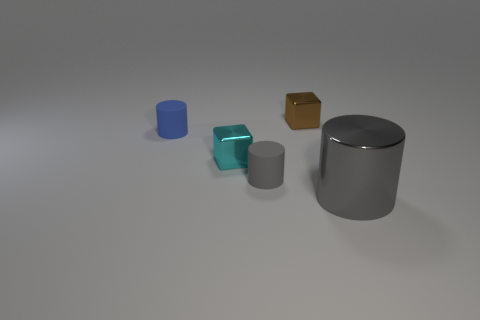Add 3 tiny blocks. How many objects exist? 8 Subtract all cubes. How many objects are left? 3 Add 3 yellow metallic cylinders. How many yellow metallic cylinders exist? 3 Subtract 1 cyan blocks. How many objects are left? 4 Subtract all brown cubes. Subtract all gray metallic things. How many objects are left? 3 Add 4 rubber cylinders. How many rubber cylinders are left? 6 